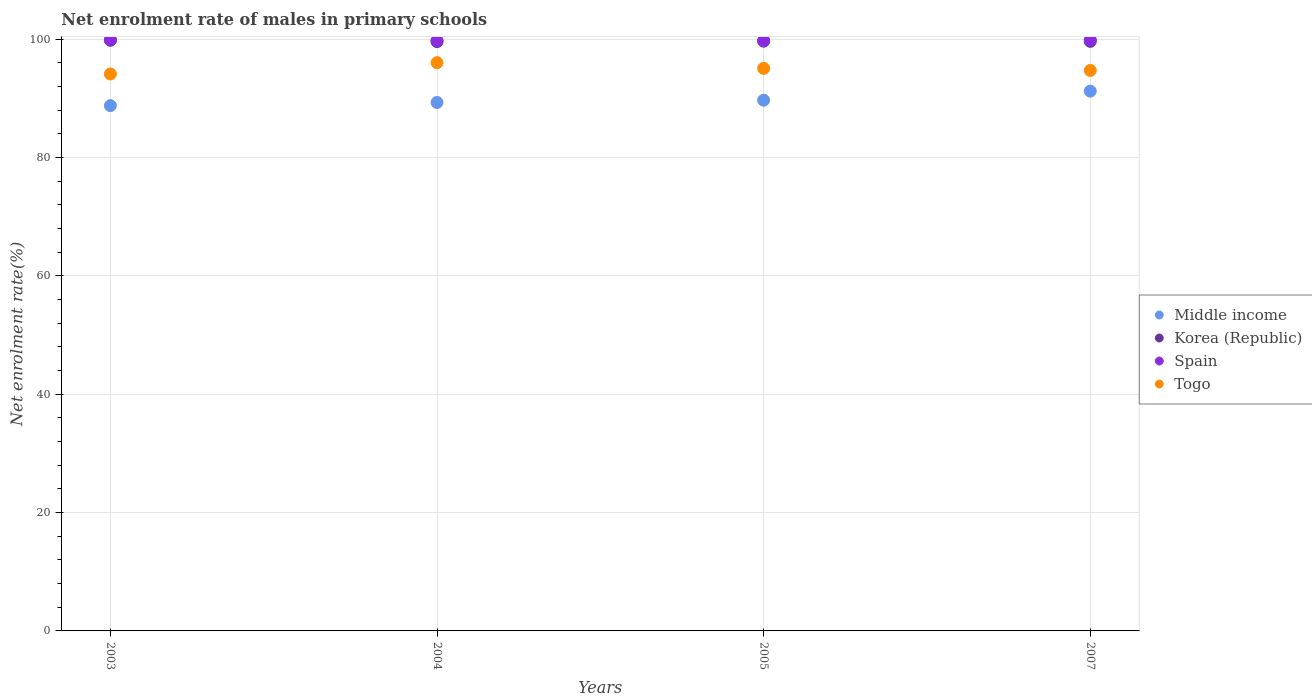How many different coloured dotlines are there?
Offer a very short reply. 4. Is the number of dotlines equal to the number of legend labels?
Provide a short and direct response. Yes. What is the net enrolment rate of males in primary schools in Spain in 2003?
Offer a terse response. 99.83. Across all years, what is the maximum net enrolment rate of males in primary schools in Middle income?
Give a very brief answer. 91.21. Across all years, what is the minimum net enrolment rate of males in primary schools in Korea (Republic)?
Provide a succinct answer. 99.58. In which year was the net enrolment rate of males in primary schools in Korea (Republic) minimum?
Provide a succinct answer. 2004. What is the total net enrolment rate of males in primary schools in Togo in the graph?
Ensure brevity in your answer.  379.87. What is the difference between the net enrolment rate of males in primary schools in Spain in 2003 and that in 2004?
Your response must be concise. 0.1. What is the difference between the net enrolment rate of males in primary schools in Spain in 2004 and the net enrolment rate of males in primary schools in Togo in 2005?
Your answer should be very brief. 4.68. What is the average net enrolment rate of males in primary schools in Middle income per year?
Ensure brevity in your answer.  89.73. In the year 2005, what is the difference between the net enrolment rate of males in primary schools in Middle income and net enrolment rate of males in primary schools in Spain?
Keep it short and to the point. -10.09. What is the ratio of the net enrolment rate of males in primary schools in Togo in 2004 to that in 2005?
Your answer should be very brief. 1.01. Is the net enrolment rate of males in primary schools in Togo in 2003 less than that in 2004?
Give a very brief answer. Yes. What is the difference between the highest and the second highest net enrolment rate of males in primary schools in Togo?
Make the answer very short. 0.96. What is the difference between the highest and the lowest net enrolment rate of males in primary schools in Korea (Republic)?
Keep it short and to the point. 0.24. Is it the case that in every year, the sum of the net enrolment rate of males in primary schools in Middle income and net enrolment rate of males in primary schools in Togo  is greater than the net enrolment rate of males in primary schools in Spain?
Give a very brief answer. Yes. How many dotlines are there?
Offer a very short reply. 4. How many years are there in the graph?
Offer a very short reply. 4. Are the values on the major ticks of Y-axis written in scientific E-notation?
Provide a short and direct response. No. Does the graph contain grids?
Ensure brevity in your answer.  Yes. Where does the legend appear in the graph?
Give a very brief answer. Center right. How are the legend labels stacked?
Keep it short and to the point. Vertical. What is the title of the graph?
Provide a short and direct response. Net enrolment rate of males in primary schools. Does "Korea (Republic)" appear as one of the legend labels in the graph?
Your answer should be compact. Yes. What is the label or title of the Y-axis?
Give a very brief answer. Net enrolment rate(%). What is the Net enrolment rate(%) in Middle income in 2003?
Offer a very short reply. 88.76. What is the Net enrolment rate(%) in Korea (Republic) in 2003?
Make the answer very short. 99.82. What is the Net enrolment rate(%) in Spain in 2003?
Make the answer very short. 99.83. What is the Net enrolment rate(%) in Togo in 2003?
Your response must be concise. 94.1. What is the Net enrolment rate(%) in Middle income in 2004?
Keep it short and to the point. 89.29. What is the Net enrolment rate(%) of Korea (Republic) in 2004?
Make the answer very short. 99.58. What is the Net enrolment rate(%) of Spain in 2004?
Keep it short and to the point. 99.73. What is the Net enrolment rate(%) of Togo in 2004?
Offer a very short reply. 96.01. What is the Net enrolment rate(%) of Middle income in 2005?
Offer a terse response. 89.68. What is the Net enrolment rate(%) of Korea (Republic) in 2005?
Your answer should be very brief. 99.65. What is the Net enrolment rate(%) in Spain in 2005?
Your answer should be compact. 99.76. What is the Net enrolment rate(%) in Togo in 2005?
Keep it short and to the point. 95.05. What is the Net enrolment rate(%) of Middle income in 2007?
Offer a very short reply. 91.21. What is the Net enrolment rate(%) in Korea (Republic) in 2007?
Your answer should be compact. 99.62. What is the Net enrolment rate(%) in Spain in 2007?
Provide a succinct answer. 99.87. What is the Net enrolment rate(%) in Togo in 2007?
Make the answer very short. 94.7. Across all years, what is the maximum Net enrolment rate(%) in Middle income?
Provide a succinct answer. 91.21. Across all years, what is the maximum Net enrolment rate(%) of Korea (Republic)?
Keep it short and to the point. 99.82. Across all years, what is the maximum Net enrolment rate(%) of Spain?
Ensure brevity in your answer.  99.87. Across all years, what is the maximum Net enrolment rate(%) in Togo?
Your answer should be compact. 96.01. Across all years, what is the minimum Net enrolment rate(%) of Middle income?
Provide a short and direct response. 88.76. Across all years, what is the minimum Net enrolment rate(%) in Korea (Republic)?
Offer a terse response. 99.58. Across all years, what is the minimum Net enrolment rate(%) of Spain?
Ensure brevity in your answer.  99.73. Across all years, what is the minimum Net enrolment rate(%) in Togo?
Your response must be concise. 94.1. What is the total Net enrolment rate(%) in Middle income in the graph?
Provide a succinct answer. 358.93. What is the total Net enrolment rate(%) in Korea (Republic) in the graph?
Your response must be concise. 398.67. What is the total Net enrolment rate(%) in Spain in the graph?
Provide a short and direct response. 399.2. What is the total Net enrolment rate(%) of Togo in the graph?
Make the answer very short. 379.87. What is the difference between the Net enrolment rate(%) in Middle income in 2003 and that in 2004?
Make the answer very short. -0.53. What is the difference between the Net enrolment rate(%) of Korea (Republic) in 2003 and that in 2004?
Your answer should be compact. 0.24. What is the difference between the Net enrolment rate(%) of Spain in 2003 and that in 2004?
Keep it short and to the point. 0.1. What is the difference between the Net enrolment rate(%) of Togo in 2003 and that in 2004?
Your response must be concise. -1.91. What is the difference between the Net enrolment rate(%) in Middle income in 2003 and that in 2005?
Offer a very short reply. -0.92. What is the difference between the Net enrolment rate(%) in Korea (Republic) in 2003 and that in 2005?
Offer a very short reply. 0.17. What is the difference between the Net enrolment rate(%) of Spain in 2003 and that in 2005?
Offer a very short reply. 0.07. What is the difference between the Net enrolment rate(%) in Togo in 2003 and that in 2005?
Offer a terse response. -0.95. What is the difference between the Net enrolment rate(%) of Middle income in 2003 and that in 2007?
Offer a terse response. -2.45. What is the difference between the Net enrolment rate(%) in Korea (Republic) in 2003 and that in 2007?
Your answer should be very brief. 0.2. What is the difference between the Net enrolment rate(%) in Spain in 2003 and that in 2007?
Your answer should be compact. -0.04. What is the difference between the Net enrolment rate(%) in Togo in 2003 and that in 2007?
Your answer should be very brief. -0.6. What is the difference between the Net enrolment rate(%) in Middle income in 2004 and that in 2005?
Ensure brevity in your answer.  -0.38. What is the difference between the Net enrolment rate(%) of Korea (Republic) in 2004 and that in 2005?
Provide a succinct answer. -0.07. What is the difference between the Net enrolment rate(%) in Spain in 2004 and that in 2005?
Make the answer very short. -0.03. What is the difference between the Net enrolment rate(%) of Togo in 2004 and that in 2005?
Provide a succinct answer. 0.96. What is the difference between the Net enrolment rate(%) of Middle income in 2004 and that in 2007?
Make the answer very short. -1.92. What is the difference between the Net enrolment rate(%) in Korea (Republic) in 2004 and that in 2007?
Give a very brief answer. -0.04. What is the difference between the Net enrolment rate(%) in Spain in 2004 and that in 2007?
Make the answer very short. -0.14. What is the difference between the Net enrolment rate(%) of Togo in 2004 and that in 2007?
Your answer should be very brief. 1.31. What is the difference between the Net enrolment rate(%) of Middle income in 2005 and that in 2007?
Your answer should be compact. -1.53. What is the difference between the Net enrolment rate(%) of Korea (Republic) in 2005 and that in 2007?
Offer a very short reply. 0.03. What is the difference between the Net enrolment rate(%) in Spain in 2005 and that in 2007?
Your answer should be compact. -0.11. What is the difference between the Net enrolment rate(%) of Togo in 2005 and that in 2007?
Keep it short and to the point. 0.35. What is the difference between the Net enrolment rate(%) in Middle income in 2003 and the Net enrolment rate(%) in Korea (Republic) in 2004?
Your answer should be very brief. -10.82. What is the difference between the Net enrolment rate(%) of Middle income in 2003 and the Net enrolment rate(%) of Spain in 2004?
Your answer should be very brief. -10.98. What is the difference between the Net enrolment rate(%) in Middle income in 2003 and the Net enrolment rate(%) in Togo in 2004?
Offer a very short reply. -7.26. What is the difference between the Net enrolment rate(%) in Korea (Republic) in 2003 and the Net enrolment rate(%) in Spain in 2004?
Provide a short and direct response. 0.09. What is the difference between the Net enrolment rate(%) in Korea (Republic) in 2003 and the Net enrolment rate(%) in Togo in 2004?
Make the answer very short. 3.81. What is the difference between the Net enrolment rate(%) in Spain in 2003 and the Net enrolment rate(%) in Togo in 2004?
Make the answer very short. 3.82. What is the difference between the Net enrolment rate(%) in Middle income in 2003 and the Net enrolment rate(%) in Korea (Republic) in 2005?
Your answer should be compact. -10.89. What is the difference between the Net enrolment rate(%) of Middle income in 2003 and the Net enrolment rate(%) of Spain in 2005?
Give a very brief answer. -11. What is the difference between the Net enrolment rate(%) in Middle income in 2003 and the Net enrolment rate(%) in Togo in 2005?
Your answer should be very brief. -6.3. What is the difference between the Net enrolment rate(%) in Korea (Republic) in 2003 and the Net enrolment rate(%) in Spain in 2005?
Provide a succinct answer. 0.06. What is the difference between the Net enrolment rate(%) of Korea (Republic) in 2003 and the Net enrolment rate(%) of Togo in 2005?
Give a very brief answer. 4.77. What is the difference between the Net enrolment rate(%) of Spain in 2003 and the Net enrolment rate(%) of Togo in 2005?
Your response must be concise. 4.78. What is the difference between the Net enrolment rate(%) in Middle income in 2003 and the Net enrolment rate(%) in Korea (Republic) in 2007?
Keep it short and to the point. -10.86. What is the difference between the Net enrolment rate(%) in Middle income in 2003 and the Net enrolment rate(%) in Spain in 2007?
Keep it short and to the point. -11.11. What is the difference between the Net enrolment rate(%) in Middle income in 2003 and the Net enrolment rate(%) in Togo in 2007?
Give a very brief answer. -5.95. What is the difference between the Net enrolment rate(%) of Korea (Republic) in 2003 and the Net enrolment rate(%) of Spain in 2007?
Make the answer very short. -0.05. What is the difference between the Net enrolment rate(%) in Korea (Republic) in 2003 and the Net enrolment rate(%) in Togo in 2007?
Make the answer very short. 5.12. What is the difference between the Net enrolment rate(%) of Spain in 2003 and the Net enrolment rate(%) of Togo in 2007?
Provide a succinct answer. 5.13. What is the difference between the Net enrolment rate(%) of Middle income in 2004 and the Net enrolment rate(%) of Korea (Republic) in 2005?
Offer a terse response. -10.36. What is the difference between the Net enrolment rate(%) of Middle income in 2004 and the Net enrolment rate(%) of Spain in 2005?
Offer a very short reply. -10.47. What is the difference between the Net enrolment rate(%) of Middle income in 2004 and the Net enrolment rate(%) of Togo in 2005?
Your answer should be compact. -5.76. What is the difference between the Net enrolment rate(%) of Korea (Republic) in 2004 and the Net enrolment rate(%) of Spain in 2005?
Give a very brief answer. -0.18. What is the difference between the Net enrolment rate(%) of Korea (Republic) in 2004 and the Net enrolment rate(%) of Togo in 2005?
Your answer should be compact. 4.53. What is the difference between the Net enrolment rate(%) of Spain in 2004 and the Net enrolment rate(%) of Togo in 2005?
Provide a succinct answer. 4.68. What is the difference between the Net enrolment rate(%) of Middle income in 2004 and the Net enrolment rate(%) of Korea (Republic) in 2007?
Your response must be concise. -10.33. What is the difference between the Net enrolment rate(%) of Middle income in 2004 and the Net enrolment rate(%) of Spain in 2007?
Keep it short and to the point. -10.58. What is the difference between the Net enrolment rate(%) of Middle income in 2004 and the Net enrolment rate(%) of Togo in 2007?
Offer a terse response. -5.41. What is the difference between the Net enrolment rate(%) in Korea (Republic) in 2004 and the Net enrolment rate(%) in Spain in 2007?
Ensure brevity in your answer.  -0.29. What is the difference between the Net enrolment rate(%) in Korea (Republic) in 2004 and the Net enrolment rate(%) in Togo in 2007?
Give a very brief answer. 4.88. What is the difference between the Net enrolment rate(%) of Spain in 2004 and the Net enrolment rate(%) of Togo in 2007?
Your answer should be compact. 5.03. What is the difference between the Net enrolment rate(%) in Middle income in 2005 and the Net enrolment rate(%) in Korea (Republic) in 2007?
Provide a short and direct response. -9.95. What is the difference between the Net enrolment rate(%) in Middle income in 2005 and the Net enrolment rate(%) in Spain in 2007?
Offer a terse response. -10.2. What is the difference between the Net enrolment rate(%) in Middle income in 2005 and the Net enrolment rate(%) in Togo in 2007?
Provide a succinct answer. -5.03. What is the difference between the Net enrolment rate(%) of Korea (Republic) in 2005 and the Net enrolment rate(%) of Spain in 2007?
Keep it short and to the point. -0.22. What is the difference between the Net enrolment rate(%) of Korea (Republic) in 2005 and the Net enrolment rate(%) of Togo in 2007?
Give a very brief answer. 4.95. What is the difference between the Net enrolment rate(%) in Spain in 2005 and the Net enrolment rate(%) in Togo in 2007?
Keep it short and to the point. 5.06. What is the average Net enrolment rate(%) in Middle income per year?
Your response must be concise. 89.73. What is the average Net enrolment rate(%) of Korea (Republic) per year?
Offer a terse response. 99.67. What is the average Net enrolment rate(%) in Spain per year?
Your answer should be compact. 99.8. What is the average Net enrolment rate(%) of Togo per year?
Your answer should be compact. 94.97. In the year 2003, what is the difference between the Net enrolment rate(%) in Middle income and Net enrolment rate(%) in Korea (Republic)?
Give a very brief answer. -11.07. In the year 2003, what is the difference between the Net enrolment rate(%) in Middle income and Net enrolment rate(%) in Spain?
Offer a very short reply. -11.08. In the year 2003, what is the difference between the Net enrolment rate(%) of Middle income and Net enrolment rate(%) of Togo?
Provide a succinct answer. -5.35. In the year 2003, what is the difference between the Net enrolment rate(%) of Korea (Republic) and Net enrolment rate(%) of Spain?
Offer a terse response. -0.01. In the year 2003, what is the difference between the Net enrolment rate(%) of Korea (Republic) and Net enrolment rate(%) of Togo?
Offer a terse response. 5.72. In the year 2003, what is the difference between the Net enrolment rate(%) of Spain and Net enrolment rate(%) of Togo?
Give a very brief answer. 5.73. In the year 2004, what is the difference between the Net enrolment rate(%) in Middle income and Net enrolment rate(%) in Korea (Republic)?
Provide a succinct answer. -10.29. In the year 2004, what is the difference between the Net enrolment rate(%) of Middle income and Net enrolment rate(%) of Spain?
Provide a short and direct response. -10.44. In the year 2004, what is the difference between the Net enrolment rate(%) in Middle income and Net enrolment rate(%) in Togo?
Your answer should be very brief. -6.72. In the year 2004, what is the difference between the Net enrolment rate(%) in Korea (Republic) and Net enrolment rate(%) in Spain?
Ensure brevity in your answer.  -0.15. In the year 2004, what is the difference between the Net enrolment rate(%) of Korea (Republic) and Net enrolment rate(%) of Togo?
Make the answer very short. 3.57. In the year 2004, what is the difference between the Net enrolment rate(%) in Spain and Net enrolment rate(%) in Togo?
Your answer should be very brief. 3.72. In the year 2005, what is the difference between the Net enrolment rate(%) in Middle income and Net enrolment rate(%) in Korea (Republic)?
Your answer should be very brief. -9.97. In the year 2005, what is the difference between the Net enrolment rate(%) in Middle income and Net enrolment rate(%) in Spain?
Offer a terse response. -10.09. In the year 2005, what is the difference between the Net enrolment rate(%) in Middle income and Net enrolment rate(%) in Togo?
Give a very brief answer. -5.38. In the year 2005, what is the difference between the Net enrolment rate(%) in Korea (Republic) and Net enrolment rate(%) in Spain?
Offer a terse response. -0.11. In the year 2005, what is the difference between the Net enrolment rate(%) in Korea (Republic) and Net enrolment rate(%) in Togo?
Your answer should be compact. 4.6. In the year 2005, what is the difference between the Net enrolment rate(%) in Spain and Net enrolment rate(%) in Togo?
Provide a short and direct response. 4.71. In the year 2007, what is the difference between the Net enrolment rate(%) of Middle income and Net enrolment rate(%) of Korea (Republic)?
Your answer should be very brief. -8.41. In the year 2007, what is the difference between the Net enrolment rate(%) of Middle income and Net enrolment rate(%) of Spain?
Make the answer very short. -8.66. In the year 2007, what is the difference between the Net enrolment rate(%) in Middle income and Net enrolment rate(%) in Togo?
Your response must be concise. -3.5. In the year 2007, what is the difference between the Net enrolment rate(%) in Korea (Republic) and Net enrolment rate(%) in Spain?
Your answer should be very brief. -0.25. In the year 2007, what is the difference between the Net enrolment rate(%) in Korea (Republic) and Net enrolment rate(%) in Togo?
Give a very brief answer. 4.92. In the year 2007, what is the difference between the Net enrolment rate(%) in Spain and Net enrolment rate(%) in Togo?
Your answer should be very brief. 5.17. What is the ratio of the Net enrolment rate(%) of Togo in 2003 to that in 2004?
Provide a short and direct response. 0.98. What is the ratio of the Net enrolment rate(%) of Korea (Republic) in 2003 to that in 2005?
Your answer should be very brief. 1. What is the ratio of the Net enrolment rate(%) in Middle income in 2003 to that in 2007?
Offer a very short reply. 0.97. What is the ratio of the Net enrolment rate(%) in Spain in 2003 to that in 2007?
Give a very brief answer. 1. What is the ratio of the Net enrolment rate(%) in Togo in 2003 to that in 2007?
Offer a terse response. 0.99. What is the ratio of the Net enrolment rate(%) of Spain in 2004 to that in 2005?
Offer a terse response. 1. What is the ratio of the Net enrolment rate(%) in Togo in 2004 to that in 2005?
Provide a succinct answer. 1.01. What is the ratio of the Net enrolment rate(%) in Middle income in 2004 to that in 2007?
Offer a terse response. 0.98. What is the ratio of the Net enrolment rate(%) in Spain in 2004 to that in 2007?
Keep it short and to the point. 1. What is the ratio of the Net enrolment rate(%) of Togo in 2004 to that in 2007?
Provide a short and direct response. 1.01. What is the ratio of the Net enrolment rate(%) of Middle income in 2005 to that in 2007?
Make the answer very short. 0.98. What is the ratio of the Net enrolment rate(%) in Togo in 2005 to that in 2007?
Provide a short and direct response. 1. What is the difference between the highest and the second highest Net enrolment rate(%) of Middle income?
Your answer should be very brief. 1.53. What is the difference between the highest and the second highest Net enrolment rate(%) of Korea (Republic)?
Offer a terse response. 0.17. What is the difference between the highest and the second highest Net enrolment rate(%) of Spain?
Give a very brief answer. 0.04. What is the difference between the highest and the second highest Net enrolment rate(%) in Togo?
Offer a very short reply. 0.96. What is the difference between the highest and the lowest Net enrolment rate(%) of Middle income?
Your answer should be very brief. 2.45. What is the difference between the highest and the lowest Net enrolment rate(%) in Korea (Republic)?
Your answer should be very brief. 0.24. What is the difference between the highest and the lowest Net enrolment rate(%) of Spain?
Your answer should be compact. 0.14. What is the difference between the highest and the lowest Net enrolment rate(%) in Togo?
Offer a terse response. 1.91. 